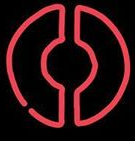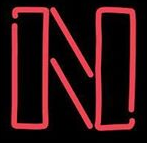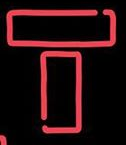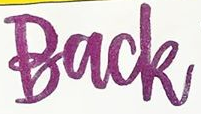Read the text content from these images in order, separated by a semicolon. O; N; T; Back 